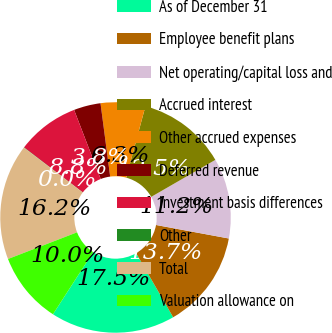<chart> <loc_0><loc_0><loc_500><loc_500><pie_chart><fcel>As of December 31<fcel>Employee benefit plans<fcel>Net operating/capital loss and<fcel>Accrued interest<fcel>Other accrued expenses<fcel>Deferred revenue<fcel>Investment basis differences<fcel>Other<fcel>Total<fcel>Valuation allowance on<nl><fcel>17.47%<fcel>13.74%<fcel>11.25%<fcel>12.49%<fcel>6.26%<fcel>3.77%<fcel>8.75%<fcel>0.04%<fcel>16.23%<fcel>10.0%<nl></chart> 